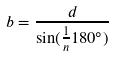<formula> <loc_0><loc_0><loc_500><loc_500>b = \frac { d } { \sin ( \frac { 1 } { n } 1 8 0 ^ { \circ } ) }</formula> 